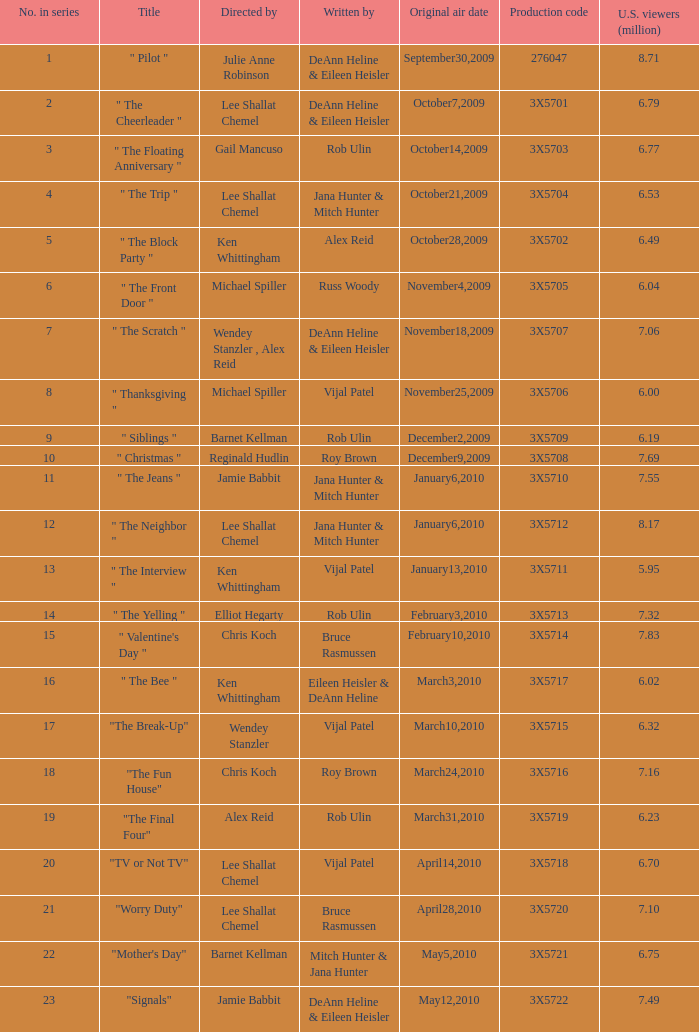Can you give me this table as a dict? {'header': ['No. in series', 'Title', 'Directed by', 'Written by', 'Original air date', 'Production code', 'U.S. viewers (million)'], 'rows': [['1', '" Pilot "', 'Julie Anne Robinson', 'DeAnn Heline & Eileen Heisler', 'September30,2009', '276047', '8.71'], ['2', '" The Cheerleader "', 'Lee Shallat Chemel', 'DeAnn Heline & Eileen Heisler', 'October7,2009', '3X5701', '6.79'], ['3', '" The Floating Anniversary "', 'Gail Mancuso', 'Rob Ulin', 'October14,2009', '3X5703', '6.77'], ['4', '" The Trip "', 'Lee Shallat Chemel', 'Jana Hunter & Mitch Hunter', 'October21,2009', '3X5704', '6.53'], ['5', '" The Block Party "', 'Ken Whittingham', 'Alex Reid', 'October28,2009', '3X5702', '6.49'], ['6', '" The Front Door "', 'Michael Spiller', 'Russ Woody', 'November4,2009', '3X5705', '6.04'], ['7', '" The Scratch "', 'Wendey Stanzler , Alex Reid', 'DeAnn Heline & Eileen Heisler', 'November18,2009', '3X5707', '7.06'], ['8', '" Thanksgiving "', 'Michael Spiller', 'Vijal Patel', 'November25,2009', '3X5706', '6.00'], ['9', '" Siblings "', 'Barnet Kellman', 'Rob Ulin', 'December2,2009', '3X5709', '6.19'], ['10', '" Christmas "', 'Reginald Hudlin', 'Roy Brown', 'December9,2009', '3X5708', '7.69'], ['11', '" The Jeans "', 'Jamie Babbit', 'Jana Hunter & Mitch Hunter', 'January6,2010', '3X5710', '7.55'], ['12', '" The Neighbor "', 'Lee Shallat Chemel', 'Jana Hunter & Mitch Hunter', 'January6,2010', '3X5712', '8.17'], ['13', '" The Interview "', 'Ken Whittingham', 'Vijal Patel', 'January13,2010', '3X5711', '5.95'], ['14', '" The Yelling "', 'Elliot Hegarty', 'Rob Ulin', 'February3,2010', '3X5713', '7.32'], ['15', '" Valentine\'s Day "', 'Chris Koch', 'Bruce Rasmussen', 'February10,2010', '3X5714', '7.83'], ['16', '" The Bee "', 'Ken Whittingham', 'Eileen Heisler & DeAnn Heline', 'March3,2010', '3X5717', '6.02'], ['17', '"The Break-Up"', 'Wendey Stanzler', 'Vijal Patel', 'March10,2010', '3X5715', '6.32'], ['18', '"The Fun House"', 'Chris Koch', 'Roy Brown', 'March24,2010', '3X5716', '7.16'], ['19', '"The Final Four"', 'Alex Reid', 'Rob Ulin', 'March31,2010', '3X5719', '6.23'], ['20', '"TV or Not TV"', 'Lee Shallat Chemel', 'Vijal Patel', 'April14,2010', '3X5718', '6.70'], ['21', '"Worry Duty"', 'Lee Shallat Chemel', 'Bruce Rasmussen', 'April28,2010', '3X5720', '7.10'], ['22', '"Mother\'s Day"', 'Barnet Kellman', 'Mitch Hunter & Jana Hunter', 'May5,2010', '3X5721', '6.75'], ['23', '"Signals"', 'Jamie Babbit', 'DeAnn Heline & Eileen Heisler', 'May12,2010', '3X5722', '7.49']]} What is the title of the episode Alex Reid directed? "The Final Four". 